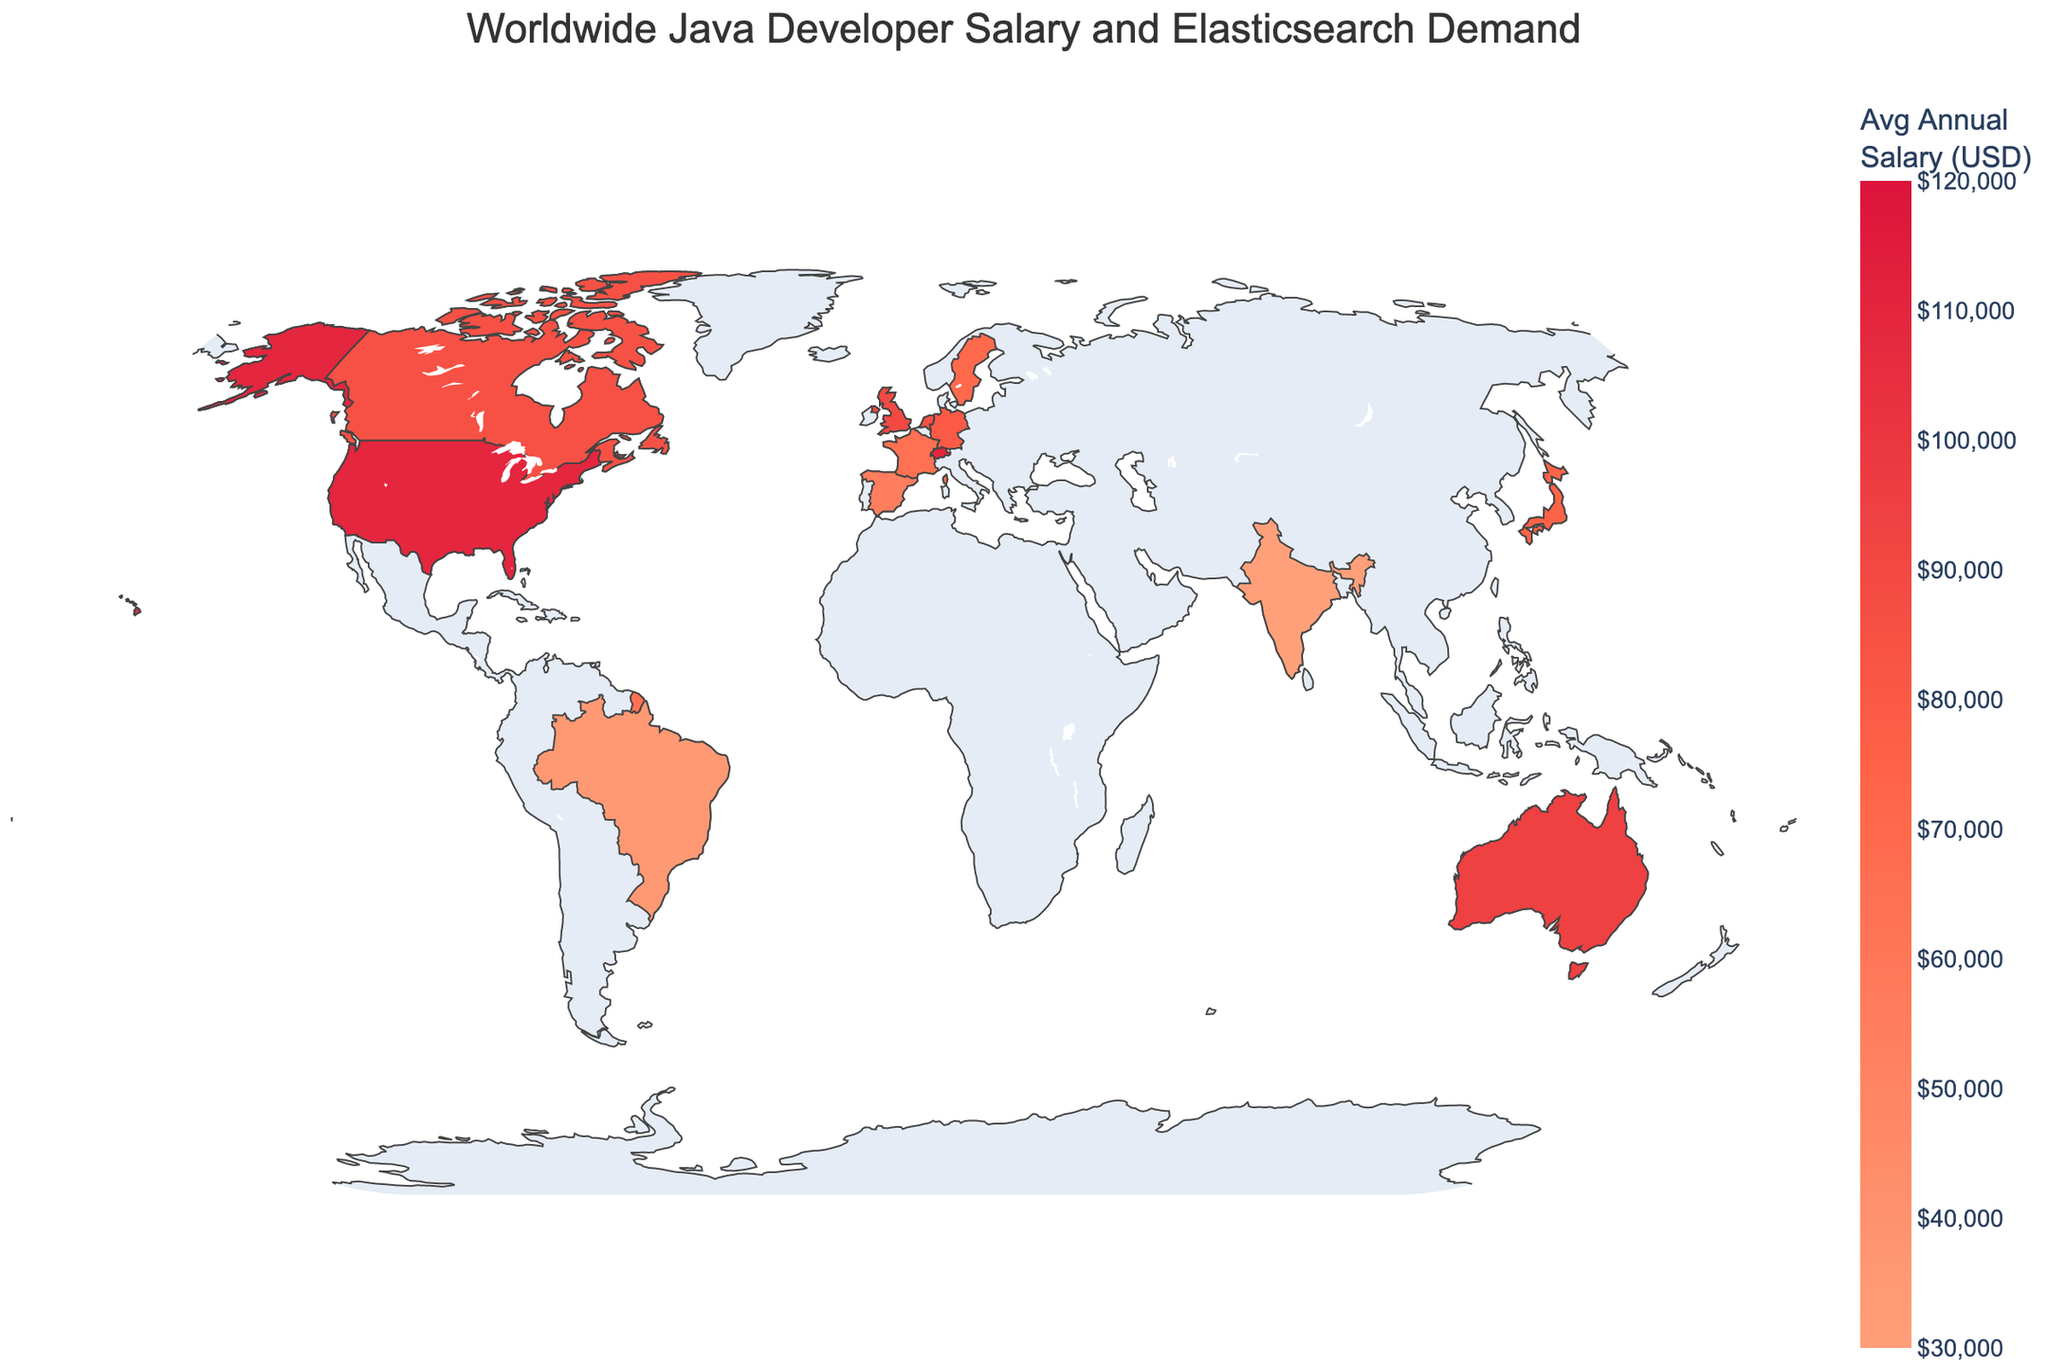Which country has the highest average annual salary for Java developers? From the color scale and the data, the United States has the highest salary on the West Coast at $120,000 per year.
Answer: United States, West Coast What is the average annual salary for Java developers in Zurich, Switzerland? The figure displays the average annual salary for Java developers in different countries and regions, and Zurich, Switzerland, is indicated to have an average salary of $110,000 per year.
Answer: $110,000 How does the Elasticsearch demand vary in regions with high salaries compared to those with low salaries? Regions with high salaries such as the US West Coast ($120,000) and East Coast ($110,000) have a 'High' demand for Elasticsearch. In contrast, regions like Spain (Madrid) with lower salaries ($55,000) have a 'Low' demand.
Answer: High salaries generally show high Elasticsearch demand, while low salaries show low demand What is the difference in average annual salary between Java developers in Bangalore, India, and Berlin, Germany? Bangalore, India, has an average annual salary of $30,000, and Berlin, Germany, has $80,000. The difference is calculated by subtracting $30,000 from $80,000, resulting in a $50,000 difference.
Answer: $50,000 Which region in the United Kingdom has been analyzed in the figure, and what is its average annual salary and Elasticsearch demand? The figure shows that London in the United Kingdom has been analyzed, with an average annual salary of $90,000 and a high Elasticsearch demand.
Answer: London, $90,000, High In which region of Japan is the salary data shown, and what is its level of Elasticsearch demand? The salary data for Japan is shown for Tokyo, with a low level of Elasticsearch demand.
Answer: Tokyo, Low Which country in South America has been analyzed, and what is the average salary for Java developers there? The country analyzed in South America is Brazil, specifically Sao Paulo, with an average salary of $35,000 for Java developers.
Answer: Brazil, $35,000 What is the relationship between the average annual salaries in Sydney, Australia, and Toronto, Canada? Both Sydney, Australia, and Toronto, Canada, have similar average annual salaries for Java developers. Sydney has $95,000, and Toronto has $85,000.
Answer: Similar, $95,000 and $85,000 Compare the Elasticsearch demand in Singapore and France, and state their respective average salaries. Singapore has a medium Elasticsearch demand with an average salary of $90,000, while France has a low demand with $65,000.
Answer: Medium with $90,000 in Singapore, Low with $65,000 in France Identify the region with the lowest average annual salary and specify its Elasticsearch demand. The region with the lowest average annual salary is Bangalore, India, at $30,000, and it has a high Elasticsearch demand.
Answer: Bangalore, India, High 